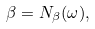<formula> <loc_0><loc_0><loc_500><loc_500>\beta = N _ { \beta } ( \omega ) ,</formula> 